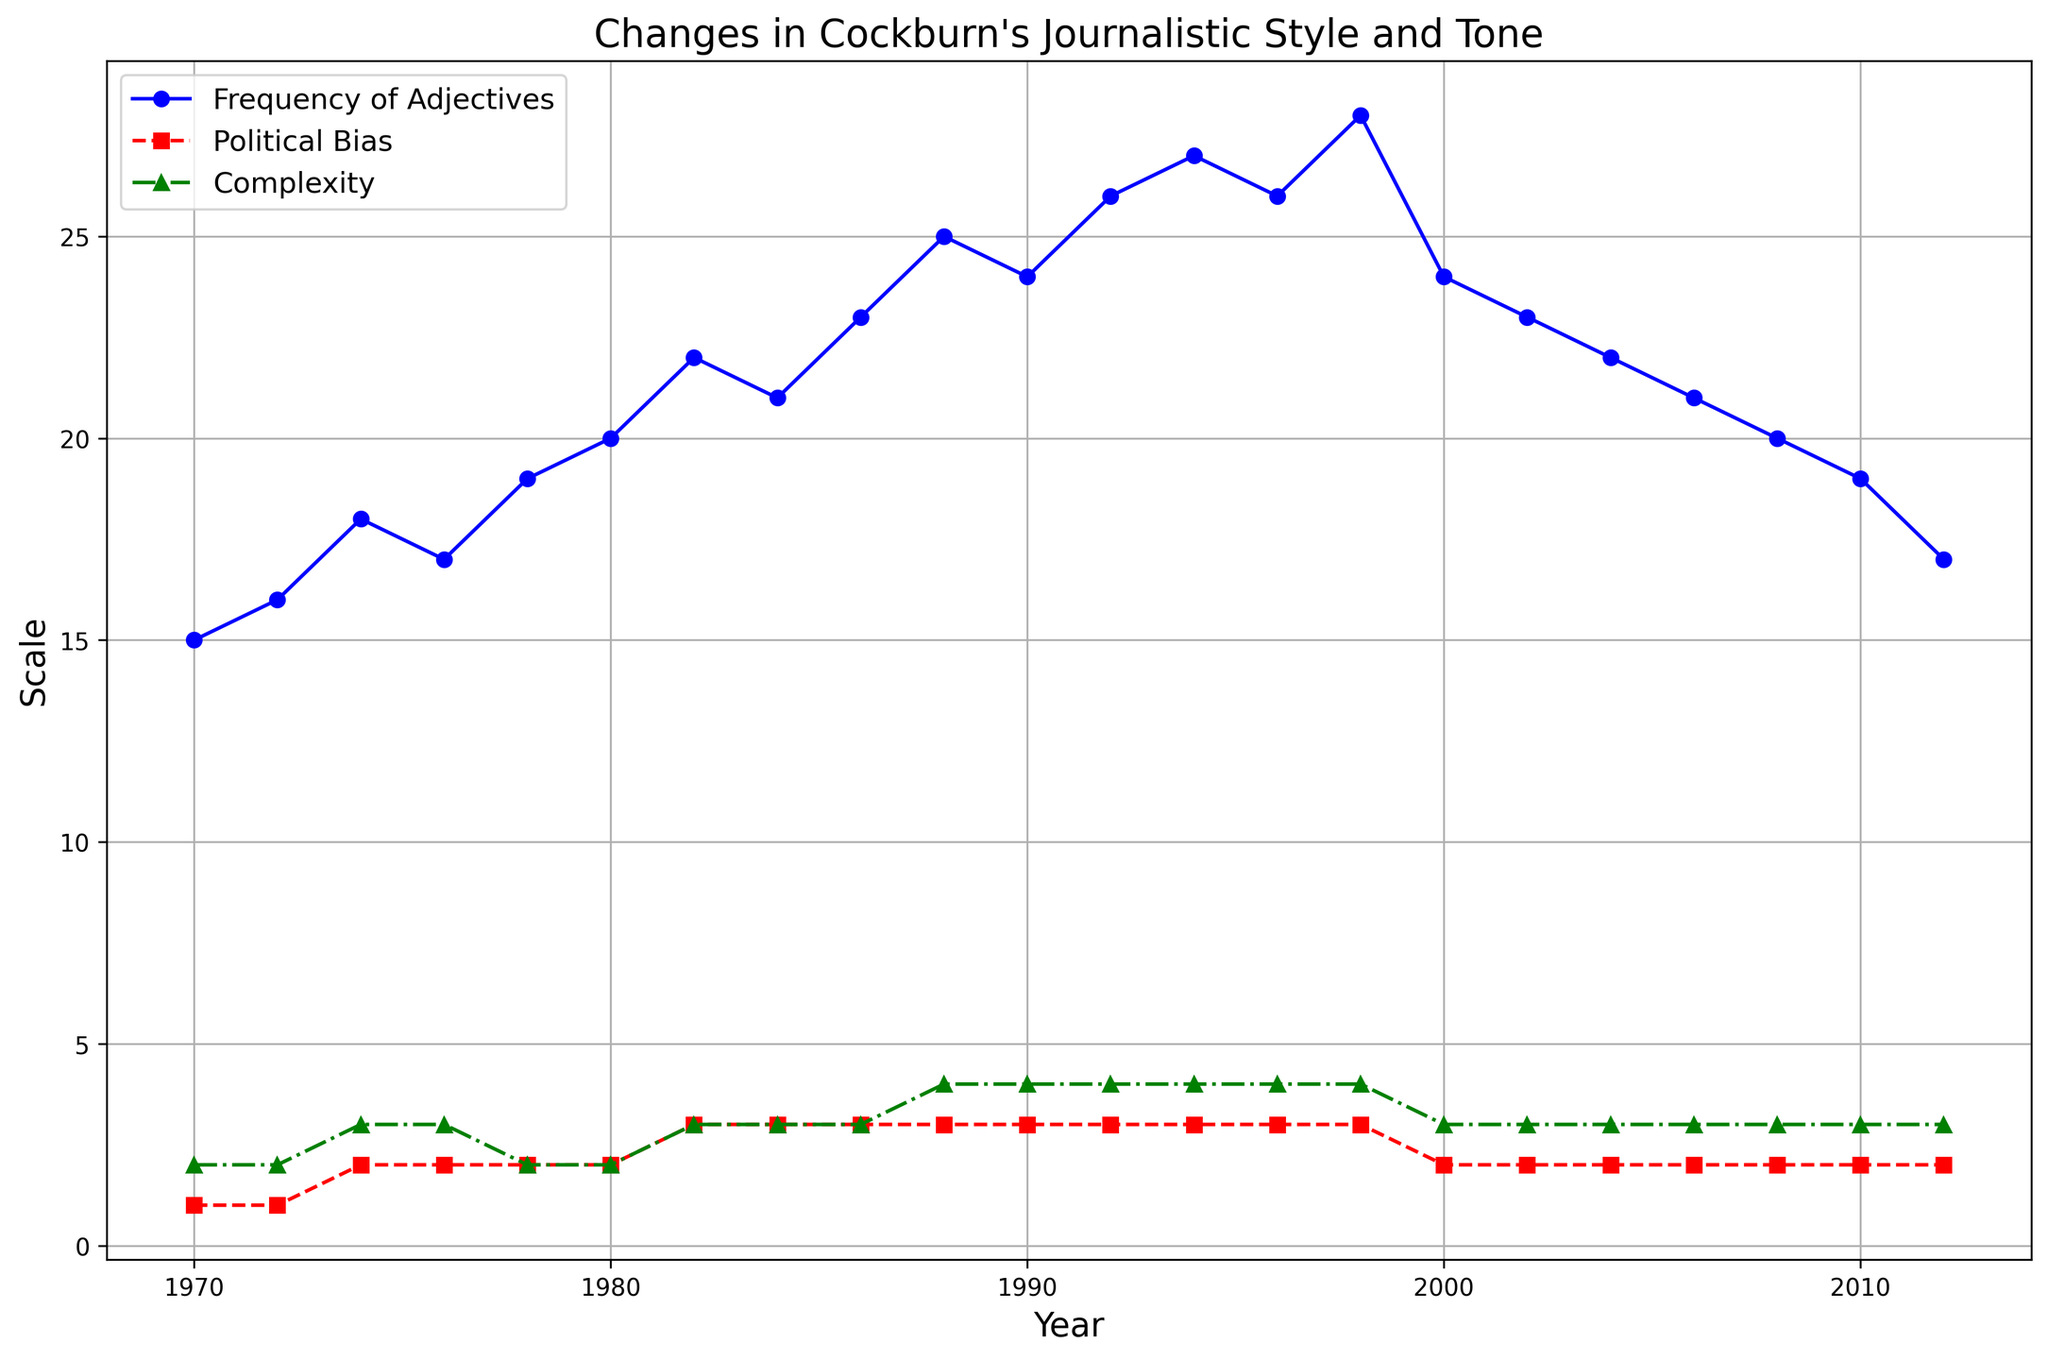What's the overall trend in the frequency of adjectives from 1970 to 2012? To determine the overall trend, look at how the line representing the frequency of adjectives changes from 1970 to 2012. The line starts at 15 in 1970, rises to a peak of 28 in 1998, then declines back to 17 in 2012.
Answer: Initially increasing, then decreasing In which year did the political bias first reach a high level? Look for the red line with square markers. The political bias reaches a high level (value of 3) for the first time in 1982.
Answer: 1982 Between 1982 and 1992, how did the complexity change? Identify the green line with triangle markers from 1982 to 1992. The complexity was high (value of 3) in 1982 and increased to very high (value of 4) by 1992.
Answer: Increased Which year had the highest frequency of adjectives and what was the corresponding political bias level? The highest frequency of adjectives is 28. Find this point along the blue line, which occurs in 1998. The political bias in that year, according to the red line with square markers, was high (value of 3).
Answer: 1998, high How does the frequency of adjectives compare from 1978 to 2002? Examine the blue line markers at these two years. The frequency in 1978 was 19, while in 2002, it was 23.
Answer: Increased What is the average frequency of adjectives in the years marked as 'Outspoken'? Identify the years marked as 'Outspoken' from 1988 to 1994. The frequencies for these years are 25, 24, and 26. The average is calculated as (25 + 24 + 26) / 3 = 25.
Answer: 25 Is there any year where both the frequency of adjectives and complexity were at their minimum values recorded? Out of all the years, identify the minimum values of frequency (15) and complexity (2). Check if both occur in the same year. The lowest frequency in 1970 & complexity in 1970, complexities were always at least Medium (2).
Answer: No Are there any years where the tone shifted from 'Aggressive' back to 'Reflective'? The tone was categorized as 'Aggressive' from 1994 to 1998 and 'Reflective' from 2000 to 2012. Thus, there was a shift from 'Aggressive' in 1998 to 'Reflective' in 2000.
Answer: Yes, from 1998 to 2000 What changes occurred in the journalistic style in terms of complexity after 2000? Identify the green line with triangle markers starting from 2000 onwards. The complexity was high (value of 3) in 2000 and remained high through 2012.
Answer: No change 